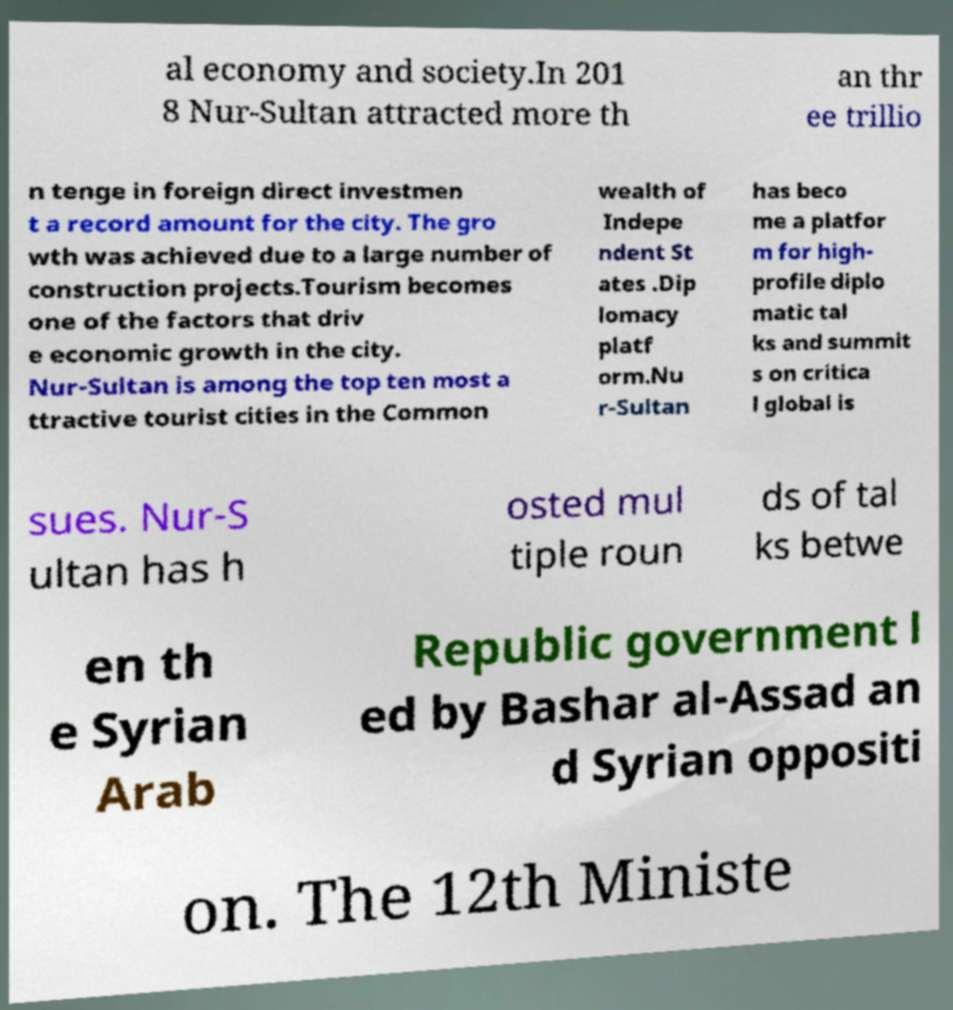Please identify and transcribe the text found in this image. al economy and society.In 201 8 Nur-Sultan attracted more th an thr ee trillio n tenge in foreign direct investmen t a record amount for the city. The gro wth was achieved due to a large number of construction projects.Tourism becomes one of the factors that driv e economic growth in the city. Nur-Sultan is among the top ten most a ttractive tourist cities in the Common wealth of Indepe ndent St ates .Dip lomacy platf orm.Nu r-Sultan has beco me a platfor m for high- profile diplo matic tal ks and summit s on critica l global is sues. Nur-S ultan has h osted mul tiple roun ds of tal ks betwe en th e Syrian Arab Republic government l ed by Bashar al-Assad an d Syrian oppositi on. The 12th Ministe 